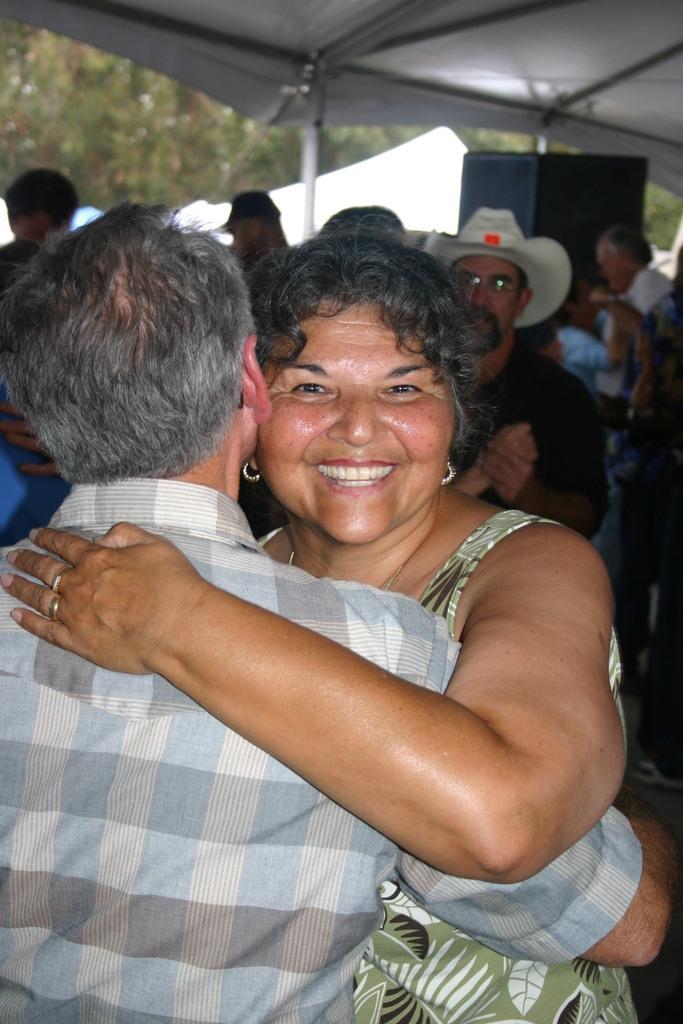Please provide a concise description of this image. In this image, we can see two people man and woman are hugging to each other. In the background, we can see group of people, speaker, tent, trees. At the top, we can see a roof. 